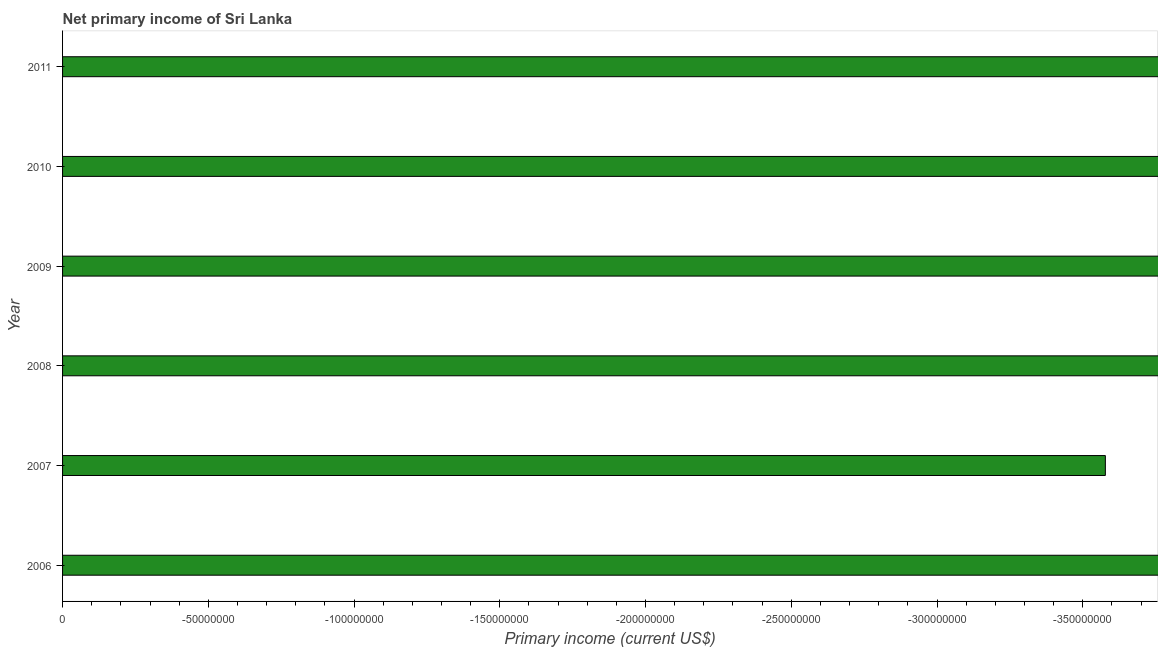Does the graph contain grids?
Offer a terse response. No. What is the title of the graph?
Make the answer very short. Net primary income of Sri Lanka. What is the label or title of the X-axis?
Your answer should be very brief. Primary income (current US$). What is the label or title of the Y-axis?
Your answer should be very brief. Year. What is the average amount of primary income per year?
Provide a succinct answer. 0. What is the median amount of primary income?
Make the answer very short. 0. In how many years, is the amount of primary income greater than -120000000 US$?
Provide a succinct answer. 0. How many bars are there?
Give a very brief answer. 0. Are all the bars in the graph horizontal?
Make the answer very short. Yes. What is the Primary income (current US$) in 2007?
Ensure brevity in your answer.  0. What is the Primary income (current US$) in 2008?
Your answer should be very brief. 0. What is the Primary income (current US$) in 2009?
Provide a short and direct response. 0. What is the Primary income (current US$) of 2010?
Ensure brevity in your answer.  0. What is the Primary income (current US$) of 2011?
Make the answer very short. 0. 